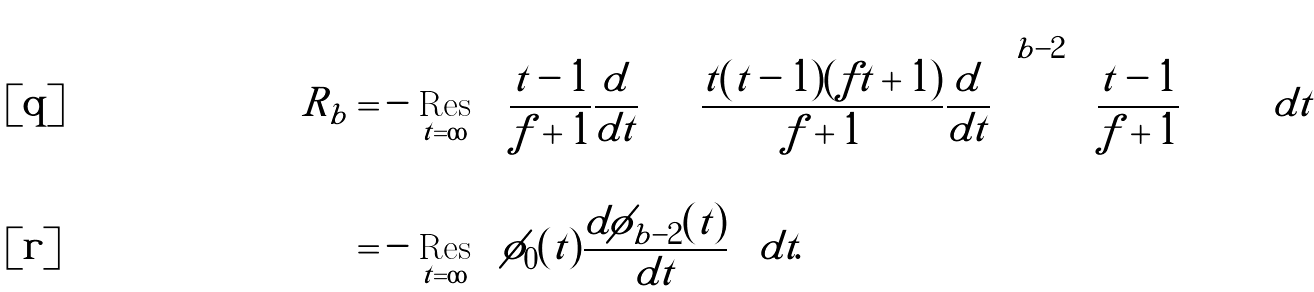<formula> <loc_0><loc_0><loc_500><loc_500>R _ { b } = & - \underset { t = \infty } { \text {Res} } \left ( \frac { t - 1 } { f + 1 } \frac { d } { d t } \left [ \left ( \frac { t ( t - 1 ) ( f t + 1 ) } { f + 1 } \frac { d } { d t } \right ) ^ { b - 2 } \left ( \frac { t - 1 } { f + 1 } \right ) \right ] \right ) d t \\ = & - \underset { t = \infty } { \text {Res} } \left ( \phi _ { 0 } ( t ) \frac { d \phi _ { b - 2 } ( t ) } { d t } \right ) d t .</formula> 